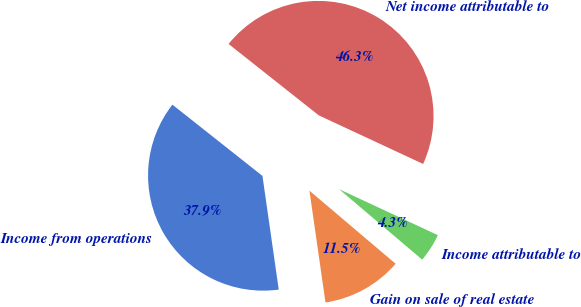Convert chart to OTSL. <chart><loc_0><loc_0><loc_500><loc_500><pie_chart><fcel>Income from operations<fcel>Gain on sale of real estate<fcel>Income attributable to<fcel>Net income attributable to<nl><fcel>37.92%<fcel>11.54%<fcel>4.26%<fcel>46.28%<nl></chart> 